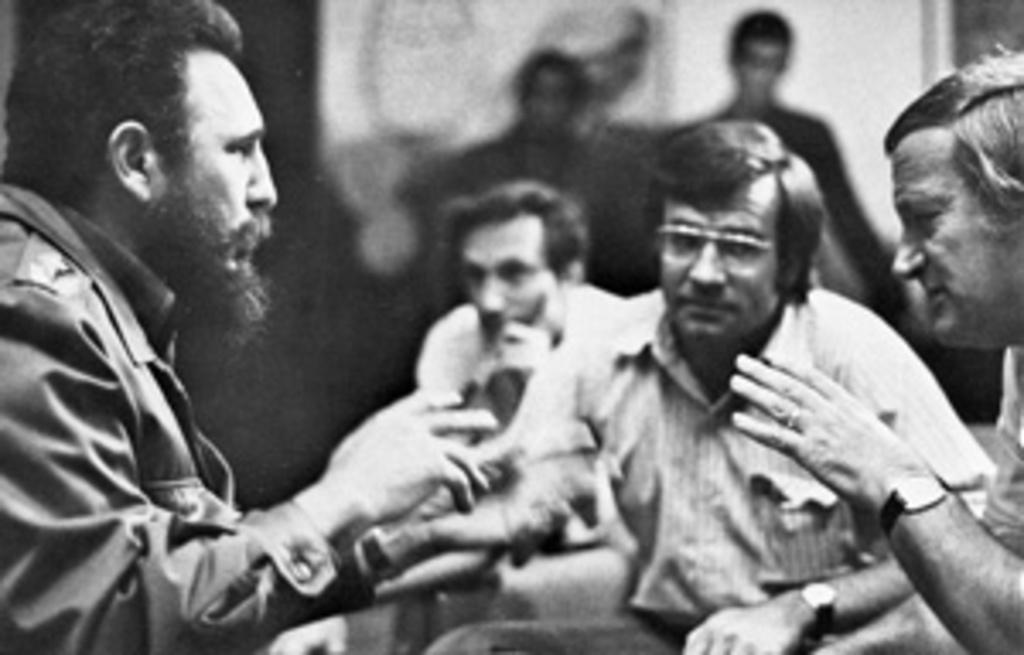What is the color scheme of the image? The image is black and white. What can be seen in the image? There are persons in the image. Can you describe the background of the image? The background of the image is blurry. What type of birds can be seen bursting out of the persons in the image? There are no birds present in the image, nor are there any instances of bursting out of the persons. 